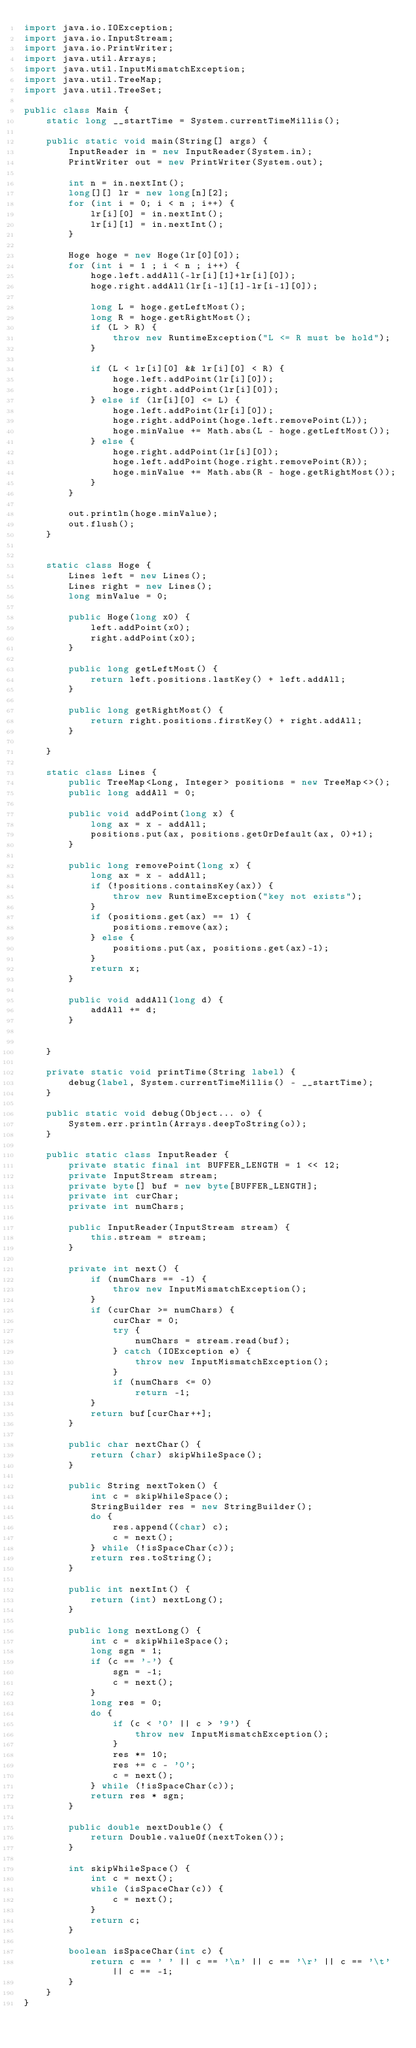Convert code to text. <code><loc_0><loc_0><loc_500><loc_500><_Java_>import java.io.IOException;
import java.io.InputStream;
import java.io.PrintWriter;
import java.util.Arrays;
import java.util.InputMismatchException;
import java.util.TreeMap;
import java.util.TreeSet;

public class Main {
    static long __startTime = System.currentTimeMillis();

    public static void main(String[] args) {
        InputReader in = new InputReader(System.in);
        PrintWriter out = new PrintWriter(System.out);

        int n = in.nextInt();
        long[][] lr = new long[n][2];
        for (int i = 0; i < n ; i++) {
            lr[i][0] = in.nextInt();
            lr[i][1] = in.nextInt();
        }

        Hoge hoge = new Hoge(lr[0][0]);
        for (int i = 1 ; i < n ; i++) {
            hoge.left.addAll(-lr[i][1]+lr[i][0]);
            hoge.right.addAll(lr[i-1][1]-lr[i-1][0]);

            long L = hoge.getLeftMost();
            long R = hoge.getRightMost();
            if (L > R) {
                throw new RuntimeException("L <= R must be hold");
            }

            if (L < lr[i][0] && lr[i][0] < R) {
                hoge.left.addPoint(lr[i][0]);
                hoge.right.addPoint(lr[i][0]);
            } else if (lr[i][0] <= L) {
                hoge.left.addPoint(lr[i][0]);
                hoge.right.addPoint(hoge.left.removePoint(L));
                hoge.minValue += Math.abs(L - hoge.getLeftMost());
            } else {
                hoge.right.addPoint(lr[i][0]);
                hoge.left.addPoint(hoge.right.removePoint(R));
                hoge.minValue += Math.abs(R - hoge.getRightMost());
            }
        }

        out.println(hoge.minValue);
        out.flush();
    }


    static class Hoge {
        Lines left = new Lines();
        Lines right = new Lines();
        long minValue = 0;

        public Hoge(long x0) {
            left.addPoint(x0);
            right.addPoint(x0);
        }

        public long getLeftMost() {
            return left.positions.lastKey() + left.addAll;
        }

        public long getRightMost() {
            return right.positions.firstKey() + right.addAll;
        }

    }

    static class Lines {
        public TreeMap<Long, Integer> positions = new TreeMap<>();
        public long addAll = 0;

        public void addPoint(long x) {
            long ax = x - addAll;
            positions.put(ax, positions.getOrDefault(ax, 0)+1);
        }

        public long removePoint(long x) {
            long ax = x - addAll;
            if (!positions.containsKey(ax)) {
                throw new RuntimeException("key not exists");
            }
            if (positions.get(ax) == 1) {
                positions.remove(ax);
            } else {
                positions.put(ax, positions.get(ax)-1);
            }
            return x;
        }

        public void addAll(long d) {
            addAll += d;
        }


    }

    private static void printTime(String label) {
        debug(label, System.currentTimeMillis() - __startTime);
    }

    public static void debug(Object... o) {
        System.err.println(Arrays.deepToString(o));
    }

    public static class InputReader {
        private static final int BUFFER_LENGTH = 1 << 12;
        private InputStream stream;
        private byte[] buf = new byte[BUFFER_LENGTH];
        private int curChar;
        private int numChars;

        public InputReader(InputStream stream) {
            this.stream = stream;
        }

        private int next() {
            if (numChars == -1) {
                throw new InputMismatchException();
            }
            if (curChar >= numChars) {
                curChar = 0;
                try {
                    numChars = stream.read(buf);
                } catch (IOException e) {
                    throw new InputMismatchException();
                }
                if (numChars <= 0)
                    return -1;
            }
            return buf[curChar++];
        }

        public char nextChar() {
            return (char) skipWhileSpace();
        }

        public String nextToken() {
            int c = skipWhileSpace();
            StringBuilder res = new StringBuilder();
            do {
                res.append((char) c);
                c = next();
            } while (!isSpaceChar(c));
            return res.toString();
        }

        public int nextInt() {
            return (int) nextLong();
        }

        public long nextLong() {
            int c = skipWhileSpace();
            long sgn = 1;
            if (c == '-') {
                sgn = -1;
                c = next();
            }
            long res = 0;
            do {
                if (c < '0' || c > '9') {
                    throw new InputMismatchException();
                }
                res *= 10;
                res += c - '0';
                c = next();
            } while (!isSpaceChar(c));
            return res * sgn;
        }

        public double nextDouble() {
            return Double.valueOf(nextToken());
        }

        int skipWhileSpace() {
            int c = next();
            while (isSpaceChar(c)) {
                c = next();
            }
            return c;
        }

        boolean isSpaceChar(int c) {
            return c == ' ' || c == '\n' || c == '\r' || c == '\t' || c == -1;
        }
    }
}</code> 